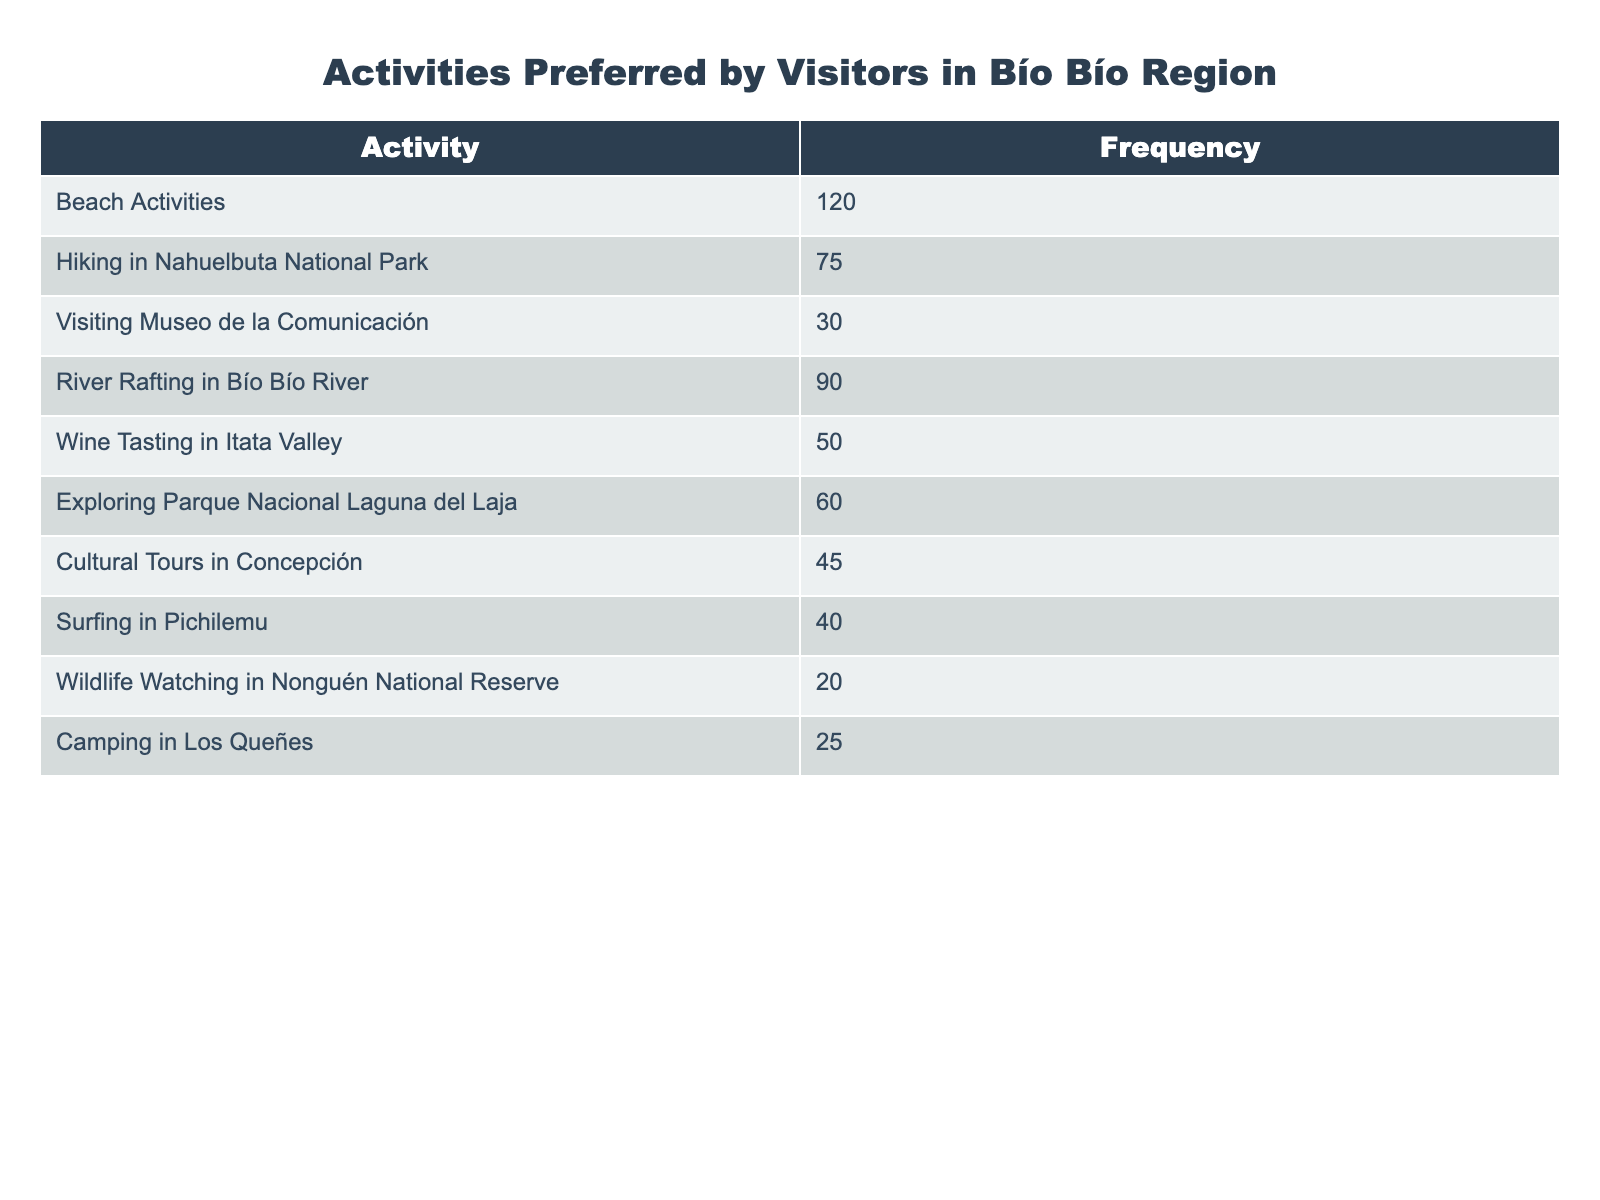What is the most preferred activity among visitors? The most preferred activity is indicated by the highest frequency in the table. Scanning through the frequencies, Beach Activities has the highest count at 120.
Answer: Beach Activities How many visitors prefer hiking in Nahuelbuta National Park? The number of visitors who prefer hiking in Nahuelbuta National Park is directly listed in the table. It shows a frequency of 75.
Answer: 75 Which activity has the lowest number of visitors? The activity with the lowest number of visitors can be determined by looking for the smallest frequency in the table. Wildlife Watching in Nonguén National Reserve has the lowest count at 20.
Answer: Wildlife Watching in Nonguén National Reserve What is the total frequency of the activities related to water (beach, river rafting, and surfing)? To find the total frequency of water-related activities, add up the frequencies of Beach Activities (120), River Rafting in Bío Bío River (90), and Surfing in Pichilemu (40). This gives 120 + 90 + 40 = 250.
Answer: 250 Is wine tasting more popular than cultural tours in Concepción? To answer this, compare the frequencies for Wine Tasting in Itata Valley (50) and Cultural Tours in Concepción (45). Since 50 is greater than 45, wine tasting is more popular.
Answer: Yes What percentage of visitors prefer exploring Parque Nacional Laguna del Laja compared to total activities? First, find the total frequency, which is the sum of all listed frequencies: 120 + 75 + 30 + 90 + 50 + 60 + 45 + 40 + 20 + 25 = 510. Then, the percentage for Parque Nacional Laguna del Laja is (60/510) * 100, which simplifies to approximately 11.76%.
Answer: 11.76% If you combine the frequencies of camping and wildlife watching, how does it compare to visiting Museo de la Comunicación? First, add the frequencies of Camping in Los Queñes (25) and Wildlife Watching in Nonguén National Reserve (20) to get a total of 45. Then, compare this with the frequency of visiting Museo de la Comunicación, which is also 30. Since 45 is greater than 30, the combined frequency is higher.
Answer: Yes How does the frequency of cultural tours relate to the total number of visitors? The total frequency of activities is 510, and the frequency of cultural tours in Concepción is 45. Since 45 is less than 510, cultural tours account for a smaller segment of the total.
Answer: Smaller segment 